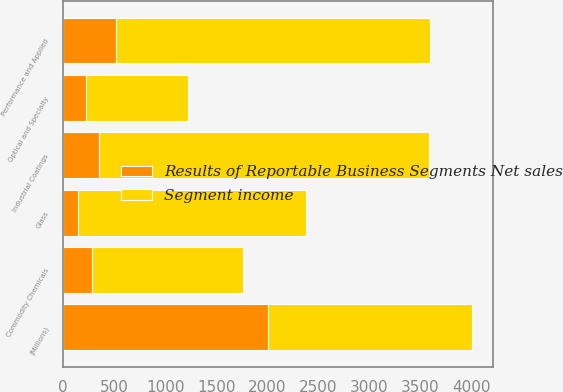<chart> <loc_0><loc_0><loc_500><loc_500><stacked_bar_chart><ecel><fcel>(Millions)<fcel>Industrial Coatings<fcel>Performance and Applied<fcel>Optical and Specialty<fcel>Commodity Chemicals<fcel>Glass<nl><fcel>Segment income<fcel>2006<fcel>3236<fcel>3088<fcel>1001<fcel>1483<fcel>2229<nl><fcel>Results of Reportable Business Segments Net sales<fcel>2006<fcel>349<fcel>514<fcel>223<fcel>285<fcel>148<nl></chart> 